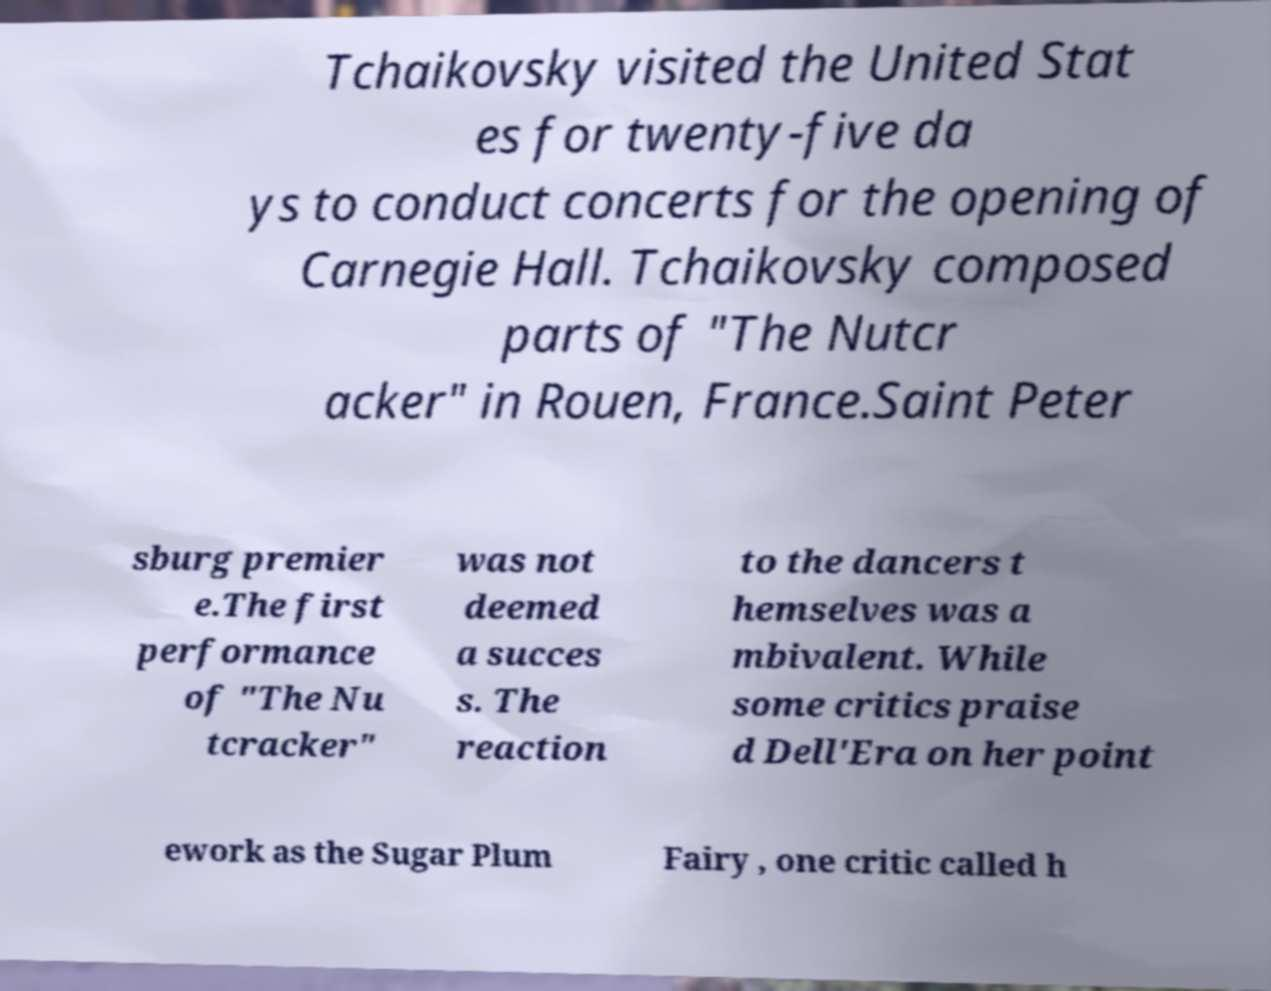Could you extract and type out the text from this image? Tchaikovsky visited the United Stat es for twenty-five da ys to conduct concerts for the opening of Carnegie Hall. Tchaikovsky composed parts of "The Nutcr acker" in Rouen, France.Saint Peter sburg premier e.The first performance of "The Nu tcracker" was not deemed a succes s. The reaction to the dancers t hemselves was a mbivalent. While some critics praise d Dell'Era on her point ework as the Sugar Plum Fairy , one critic called h 